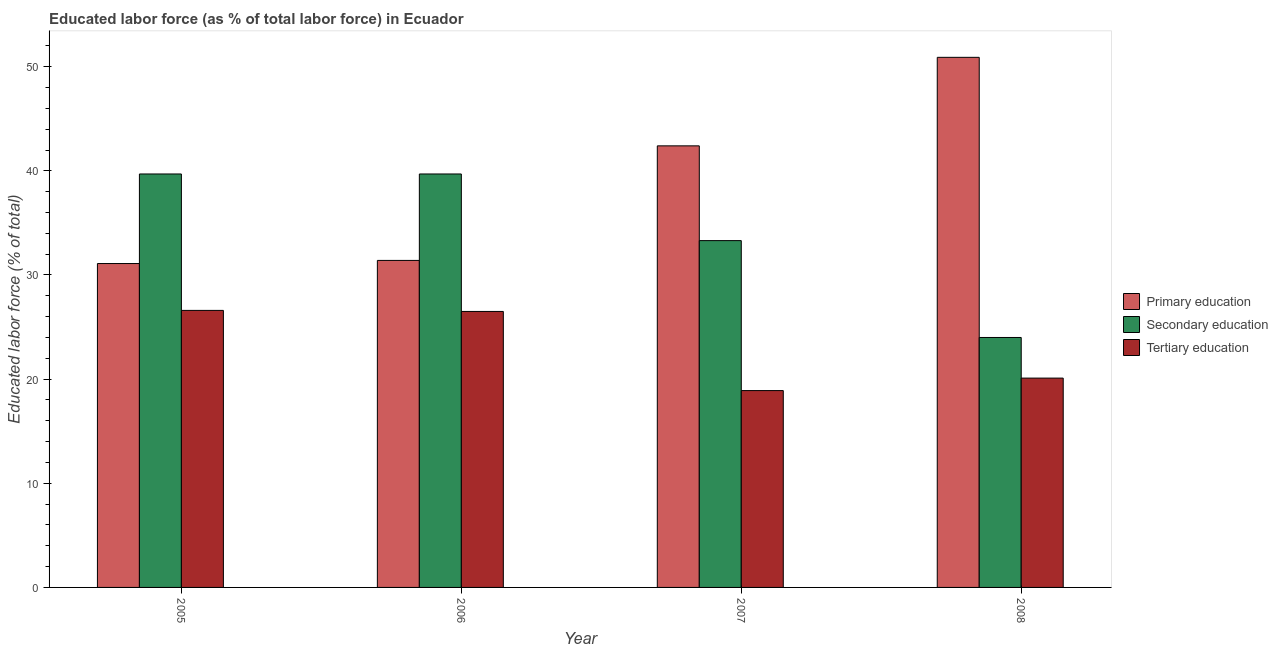How many bars are there on the 2nd tick from the right?
Offer a very short reply. 3. What is the label of the 1st group of bars from the left?
Give a very brief answer. 2005. What is the percentage of labor force who received tertiary education in 2005?
Offer a terse response. 26.6. Across all years, what is the maximum percentage of labor force who received tertiary education?
Offer a very short reply. 26.6. Across all years, what is the minimum percentage of labor force who received primary education?
Give a very brief answer. 31.1. What is the total percentage of labor force who received secondary education in the graph?
Offer a terse response. 136.7. What is the difference between the percentage of labor force who received primary education in 2005 and that in 2007?
Offer a very short reply. -11.3. What is the difference between the percentage of labor force who received primary education in 2006 and the percentage of labor force who received secondary education in 2008?
Offer a terse response. -19.5. What is the average percentage of labor force who received secondary education per year?
Your answer should be very brief. 34.18. In the year 2008, what is the difference between the percentage of labor force who received tertiary education and percentage of labor force who received primary education?
Your answer should be very brief. 0. What is the ratio of the percentage of labor force who received tertiary education in 2005 to that in 2007?
Ensure brevity in your answer.  1.41. Is the percentage of labor force who received secondary education in 2006 less than that in 2008?
Your response must be concise. No. What is the difference between the highest and the lowest percentage of labor force who received secondary education?
Offer a terse response. 15.7. In how many years, is the percentage of labor force who received primary education greater than the average percentage of labor force who received primary education taken over all years?
Make the answer very short. 2. What does the 1st bar from the left in 2006 represents?
Give a very brief answer. Primary education. What does the 3rd bar from the right in 2007 represents?
Provide a succinct answer. Primary education. How many bars are there?
Make the answer very short. 12. Are all the bars in the graph horizontal?
Provide a short and direct response. No. How many years are there in the graph?
Provide a short and direct response. 4. How are the legend labels stacked?
Keep it short and to the point. Vertical. What is the title of the graph?
Keep it short and to the point. Educated labor force (as % of total labor force) in Ecuador. Does "Natural Gas" appear as one of the legend labels in the graph?
Your answer should be compact. No. What is the label or title of the X-axis?
Give a very brief answer. Year. What is the label or title of the Y-axis?
Keep it short and to the point. Educated labor force (% of total). What is the Educated labor force (% of total) of Primary education in 2005?
Your response must be concise. 31.1. What is the Educated labor force (% of total) of Secondary education in 2005?
Your answer should be compact. 39.7. What is the Educated labor force (% of total) of Tertiary education in 2005?
Keep it short and to the point. 26.6. What is the Educated labor force (% of total) in Primary education in 2006?
Make the answer very short. 31.4. What is the Educated labor force (% of total) in Secondary education in 2006?
Give a very brief answer. 39.7. What is the Educated labor force (% of total) in Tertiary education in 2006?
Offer a very short reply. 26.5. What is the Educated labor force (% of total) of Primary education in 2007?
Make the answer very short. 42.4. What is the Educated labor force (% of total) in Secondary education in 2007?
Your answer should be very brief. 33.3. What is the Educated labor force (% of total) of Tertiary education in 2007?
Offer a very short reply. 18.9. What is the Educated labor force (% of total) in Primary education in 2008?
Make the answer very short. 50.9. What is the Educated labor force (% of total) in Tertiary education in 2008?
Ensure brevity in your answer.  20.1. Across all years, what is the maximum Educated labor force (% of total) in Primary education?
Make the answer very short. 50.9. Across all years, what is the maximum Educated labor force (% of total) in Secondary education?
Offer a terse response. 39.7. Across all years, what is the maximum Educated labor force (% of total) in Tertiary education?
Ensure brevity in your answer.  26.6. Across all years, what is the minimum Educated labor force (% of total) of Primary education?
Provide a succinct answer. 31.1. Across all years, what is the minimum Educated labor force (% of total) in Tertiary education?
Make the answer very short. 18.9. What is the total Educated labor force (% of total) of Primary education in the graph?
Make the answer very short. 155.8. What is the total Educated labor force (% of total) in Secondary education in the graph?
Give a very brief answer. 136.7. What is the total Educated labor force (% of total) of Tertiary education in the graph?
Provide a short and direct response. 92.1. What is the difference between the Educated labor force (% of total) of Primary education in 2005 and that in 2006?
Provide a succinct answer. -0.3. What is the difference between the Educated labor force (% of total) of Tertiary education in 2005 and that in 2006?
Provide a succinct answer. 0.1. What is the difference between the Educated labor force (% of total) in Secondary education in 2005 and that in 2007?
Your answer should be compact. 6.4. What is the difference between the Educated labor force (% of total) of Tertiary education in 2005 and that in 2007?
Make the answer very short. 7.7. What is the difference between the Educated labor force (% of total) in Primary education in 2005 and that in 2008?
Provide a succinct answer. -19.8. What is the difference between the Educated labor force (% of total) of Secondary education in 2005 and that in 2008?
Keep it short and to the point. 15.7. What is the difference between the Educated labor force (% of total) in Primary education in 2006 and that in 2007?
Provide a short and direct response. -11. What is the difference between the Educated labor force (% of total) of Secondary education in 2006 and that in 2007?
Provide a short and direct response. 6.4. What is the difference between the Educated labor force (% of total) in Tertiary education in 2006 and that in 2007?
Make the answer very short. 7.6. What is the difference between the Educated labor force (% of total) of Primary education in 2006 and that in 2008?
Your response must be concise. -19.5. What is the difference between the Educated labor force (% of total) of Primary education in 2007 and that in 2008?
Provide a short and direct response. -8.5. What is the difference between the Educated labor force (% of total) in Secondary education in 2007 and that in 2008?
Offer a very short reply. 9.3. What is the difference between the Educated labor force (% of total) in Primary education in 2005 and the Educated labor force (% of total) in Secondary education in 2006?
Provide a succinct answer. -8.6. What is the difference between the Educated labor force (% of total) in Secondary education in 2005 and the Educated labor force (% of total) in Tertiary education in 2006?
Keep it short and to the point. 13.2. What is the difference between the Educated labor force (% of total) of Primary education in 2005 and the Educated labor force (% of total) of Tertiary education in 2007?
Your response must be concise. 12.2. What is the difference between the Educated labor force (% of total) of Secondary education in 2005 and the Educated labor force (% of total) of Tertiary education in 2007?
Your response must be concise. 20.8. What is the difference between the Educated labor force (% of total) in Primary education in 2005 and the Educated labor force (% of total) in Tertiary education in 2008?
Provide a succinct answer. 11. What is the difference between the Educated labor force (% of total) in Secondary education in 2005 and the Educated labor force (% of total) in Tertiary education in 2008?
Offer a very short reply. 19.6. What is the difference between the Educated labor force (% of total) in Primary education in 2006 and the Educated labor force (% of total) in Secondary education in 2007?
Make the answer very short. -1.9. What is the difference between the Educated labor force (% of total) of Primary education in 2006 and the Educated labor force (% of total) of Tertiary education in 2007?
Keep it short and to the point. 12.5. What is the difference between the Educated labor force (% of total) in Secondary education in 2006 and the Educated labor force (% of total) in Tertiary education in 2007?
Provide a succinct answer. 20.8. What is the difference between the Educated labor force (% of total) of Primary education in 2006 and the Educated labor force (% of total) of Secondary education in 2008?
Make the answer very short. 7.4. What is the difference between the Educated labor force (% of total) of Primary education in 2006 and the Educated labor force (% of total) of Tertiary education in 2008?
Keep it short and to the point. 11.3. What is the difference between the Educated labor force (% of total) in Secondary education in 2006 and the Educated labor force (% of total) in Tertiary education in 2008?
Your answer should be very brief. 19.6. What is the difference between the Educated labor force (% of total) in Primary education in 2007 and the Educated labor force (% of total) in Secondary education in 2008?
Make the answer very short. 18.4. What is the difference between the Educated labor force (% of total) in Primary education in 2007 and the Educated labor force (% of total) in Tertiary education in 2008?
Your answer should be compact. 22.3. What is the difference between the Educated labor force (% of total) in Secondary education in 2007 and the Educated labor force (% of total) in Tertiary education in 2008?
Provide a short and direct response. 13.2. What is the average Educated labor force (% of total) of Primary education per year?
Offer a very short reply. 38.95. What is the average Educated labor force (% of total) in Secondary education per year?
Offer a very short reply. 34.17. What is the average Educated labor force (% of total) in Tertiary education per year?
Provide a succinct answer. 23.02. In the year 2005, what is the difference between the Educated labor force (% of total) in Primary education and Educated labor force (% of total) in Secondary education?
Offer a very short reply. -8.6. In the year 2005, what is the difference between the Educated labor force (% of total) in Primary education and Educated labor force (% of total) in Tertiary education?
Provide a succinct answer. 4.5. In the year 2006, what is the difference between the Educated labor force (% of total) in Primary education and Educated labor force (% of total) in Secondary education?
Your response must be concise. -8.3. In the year 2006, what is the difference between the Educated labor force (% of total) of Secondary education and Educated labor force (% of total) of Tertiary education?
Offer a very short reply. 13.2. In the year 2007, what is the difference between the Educated labor force (% of total) in Primary education and Educated labor force (% of total) in Secondary education?
Provide a succinct answer. 9.1. In the year 2007, what is the difference between the Educated labor force (% of total) in Secondary education and Educated labor force (% of total) in Tertiary education?
Ensure brevity in your answer.  14.4. In the year 2008, what is the difference between the Educated labor force (% of total) of Primary education and Educated labor force (% of total) of Secondary education?
Provide a short and direct response. 26.9. In the year 2008, what is the difference between the Educated labor force (% of total) in Primary education and Educated labor force (% of total) in Tertiary education?
Keep it short and to the point. 30.8. What is the ratio of the Educated labor force (% of total) of Primary education in 2005 to that in 2006?
Your response must be concise. 0.99. What is the ratio of the Educated labor force (% of total) of Secondary education in 2005 to that in 2006?
Offer a very short reply. 1. What is the ratio of the Educated labor force (% of total) in Primary education in 2005 to that in 2007?
Provide a short and direct response. 0.73. What is the ratio of the Educated labor force (% of total) of Secondary education in 2005 to that in 2007?
Give a very brief answer. 1.19. What is the ratio of the Educated labor force (% of total) in Tertiary education in 2005 to that in 2007?
Offer a very short reply. 1.41. What is the ratio of the Educated labor force (% of total) in Primary education in 2005 to that in 2008?
Your response must be concise. 0.61. What is the ratio of the Educated labor force (% of total) of Secondary education in 2005 to that in 2008?
Make the answer very short. 1.65. What is the ratio of the Educated labor force (% of total) in Tertiary education in 2005 to that in 2008?
Keep it short and to the point. 1.32. What is the ratio of the Educated labor force (% of total) of Primary education in 2006 to that in 2007?
Your response must be concise. 0.74. What is the ratio of the Educated labor force (% of total) in Secondary education in 2006 to that in 2007?
Make the answer very short. 1.19. What is the ratio of the Educated labor force (% of total) in Tertiary education in 2006 to that in 2007?
Ensure brevity in your answer.  1.4. What is the ratio of the Educated labor force (% of total) of Primary education in 2006 to that in 2008?
Give a very brief answer. 0.62. What is the ratio of the Educated labor force (% of total) in Secondary education in 2006 to that in 2008?
Provide a short and direct response. 1.65. What is the ratio of the Educated labor force (% of total) of Tertiary education in 2006 to that in 2008?
Give a very brief answer. 1.32. What is the ratio of the Educated labor force (% of total) of Primary education in 2007 to that in 2008?
Provide a succinct answer. 0.83. What is the ratio of the Educated labor force (% of total) in Secondary education in 2007 to that in 2008?
Your answer should be compact. 1.39. What is the ratio of the Educated labor force (% of total) in Tertiary education in 2007 to that in 2008?
Offer a terse response. 0.94. What is the difference between the highest and the second highest Educated labor force (% of total) of Primary education?
Provide a succinct answer. 8.5. What is the difference between the highest and the second highest Educated labor force (% of total) in Secondary education?
Make the answer very short. 0. What is the difference between the highest and the second highest Educated labor force (% of total) of Tertiary education?
Your response must be concise. 0.1. What is the difference between the highest and the lowest Educated labor force (% of total) in Primary education?
Keep it short and to the point. 19.8. What is the difference between the highest and the lowest Educated labor force (% of total) of Tertiary education?
Make the answer very short. 7.7. 